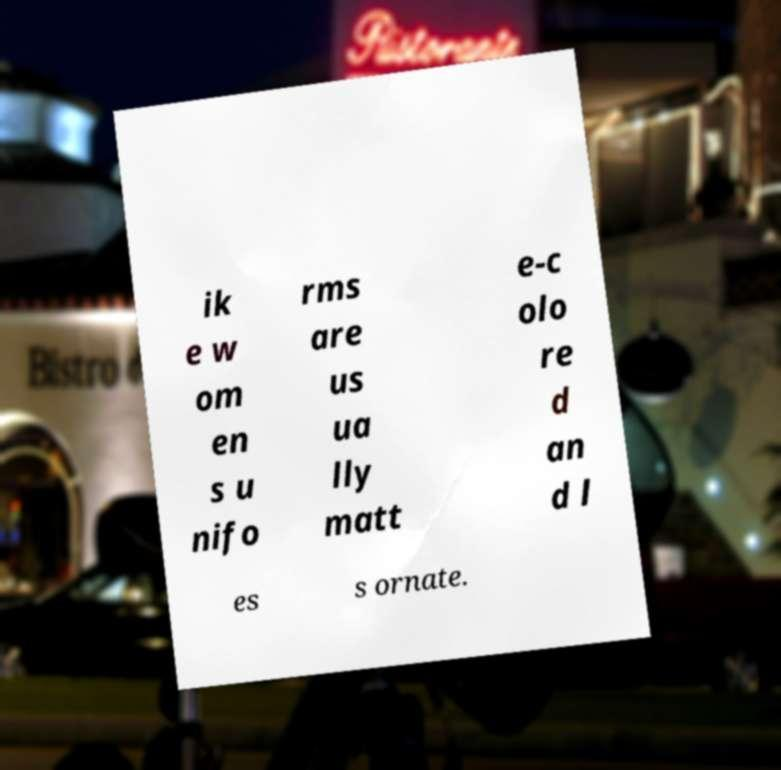Please read and relay the text visible in this image. What does it say? ik e w om en s u nifo rms are us ua lly matt e-c olo re d an d l es s ornate. 